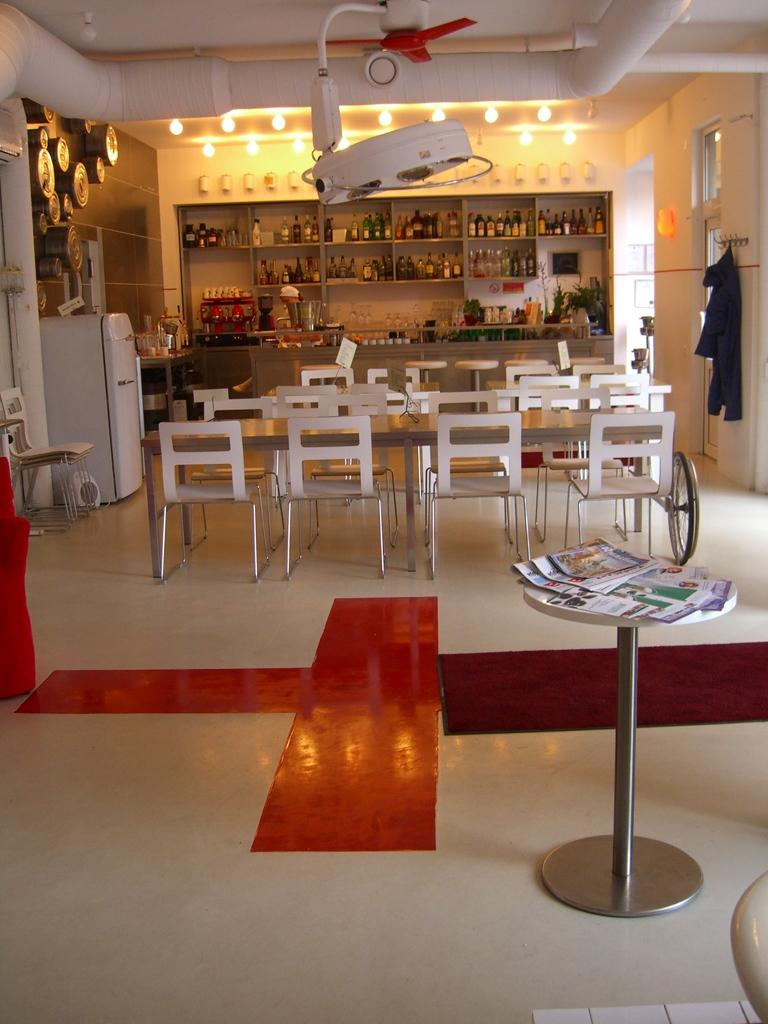What type of appliance can be seen in the image? There is a refrigerator in the image. What type of furniture is present in the image? There are chairs and tables in the image. What items can be seen on the shelves in the image? The shelves are filled with bottles in the image. What type of device is used for cooling in the image? There is a fan in the image. What type of objects are used for illumination in the image? There are lights in the image. What type of items can be seen for reading or learning in the image? There are books in the image. What is the name of the person sitting on the chair in the image? There is no person visible in the image, so it is not possible to determine their name. 